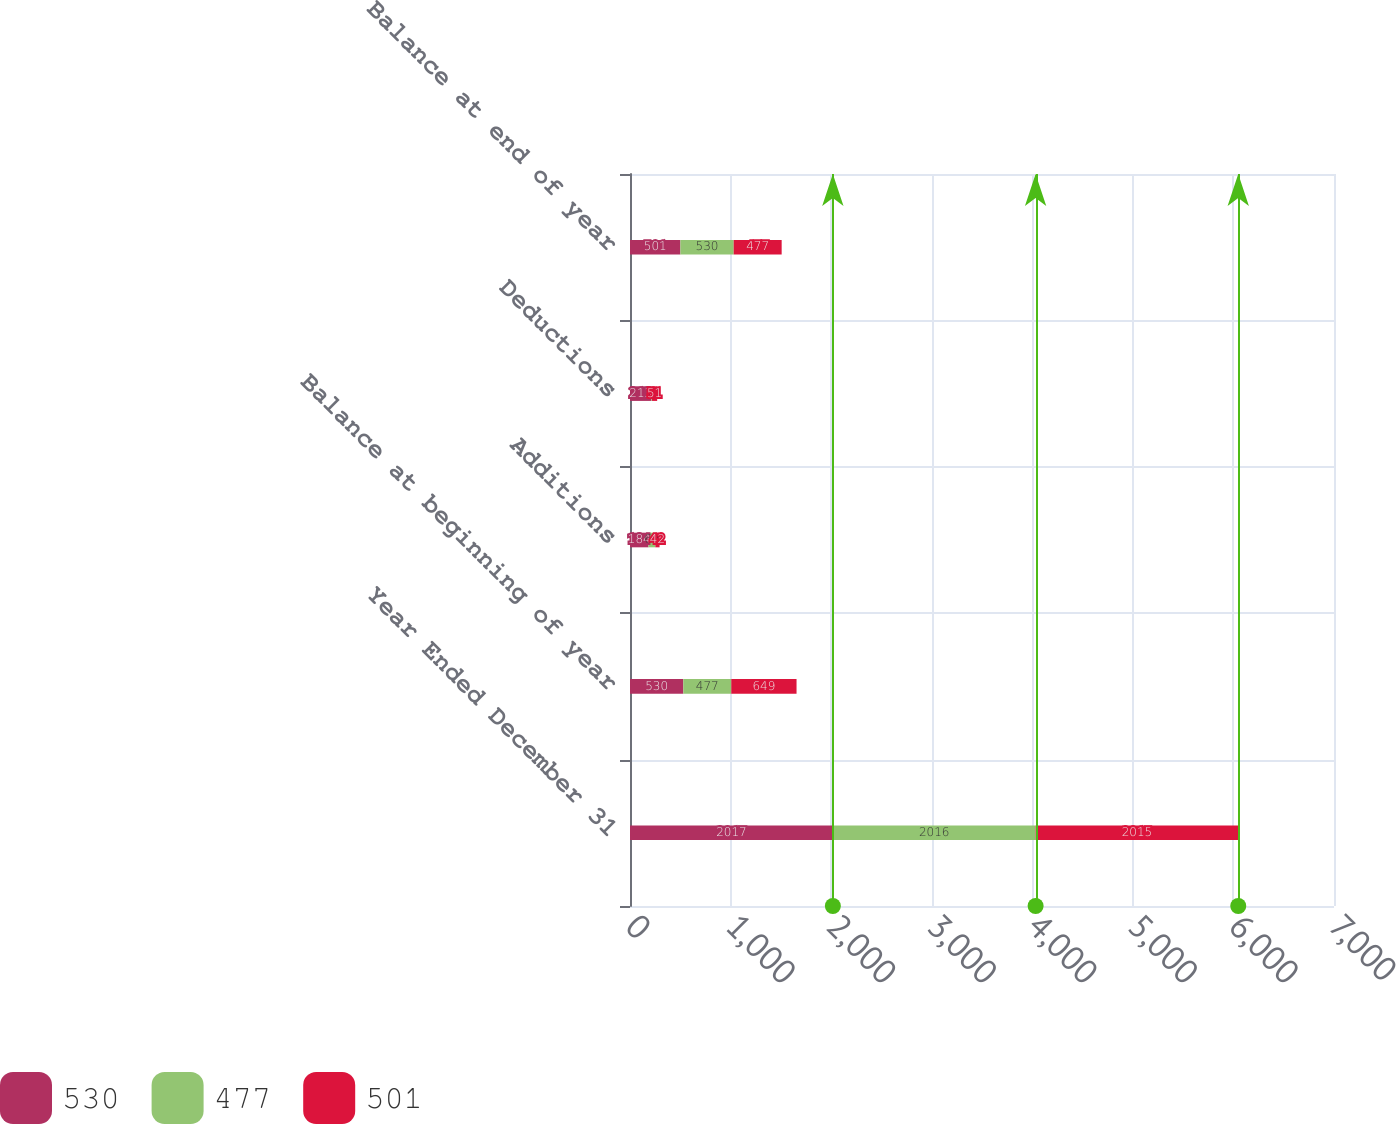<chart> <loc_0><loc_0><loc_500><loc_500><stacked_bar_chart><ecel><fcel>Year Ended December 31<fcel>Balance at beginning of year<fcel>Additions<fcel>Deductions<fcel>Balance at end of year<nl><fcel>530<fcel>2017<fcel>530<fcel>184<fcel>213<fcel>501<nl><fcel>477<fcel>2016<fcel>477<fcel>68<fcel>6<fcel>530<nl><fcel>501<fcel>2015<fcel>649<fcel>42<fcel>51<fcel>477<nl></chart> 